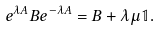Convert formula to latex. <formula><loc_0><loc_0><loc_500><loc_500>e ^ { \lambda A } B e ^ { - \lambda A } = B + \lambda \mu \mathbb { 1 } .</formula> 